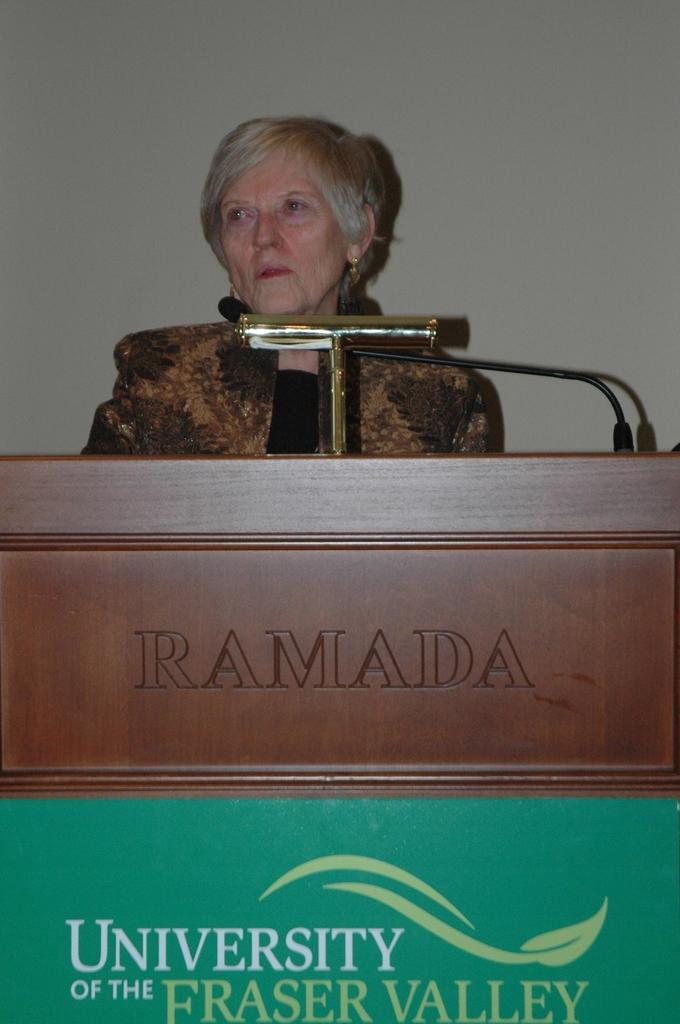Who is the main subject in the image? There is a woman in the image. What is the woman doing in the image? The woman is standing at a desk and holding a mic. What can be seen in the background of the image? There is a wall in the background of the image. What type of underwear is the woman wearing in the image? There is no information about the woman's underwear in the image. 